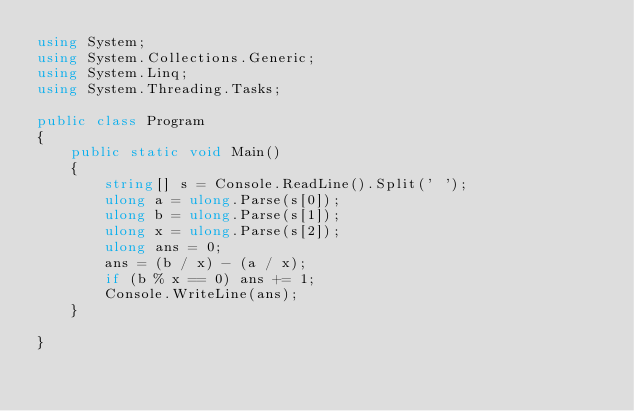Convert code to text. <code><loc_0><loc_0><loc_500><loc_500><_C#_>using System;
using System.Collections.Generic;
using System.Linq;
using System.Threading.Tasks;

public class Program
{
    public static void Main()
    {
        string[] s = Console.ReadLine().Split(' ');
        ulong a = ulong.Parse(s[0]);
        ulong b = ulong.Parse(s[1]);
        ulong x = ulong.Parse(s[2]);
        ulong ans = 0;
        ans = (b / x) - (a / x);
        if (b % x == 0) ans += 1;
        Console.WriteLine(ans);
    }

}</code> 